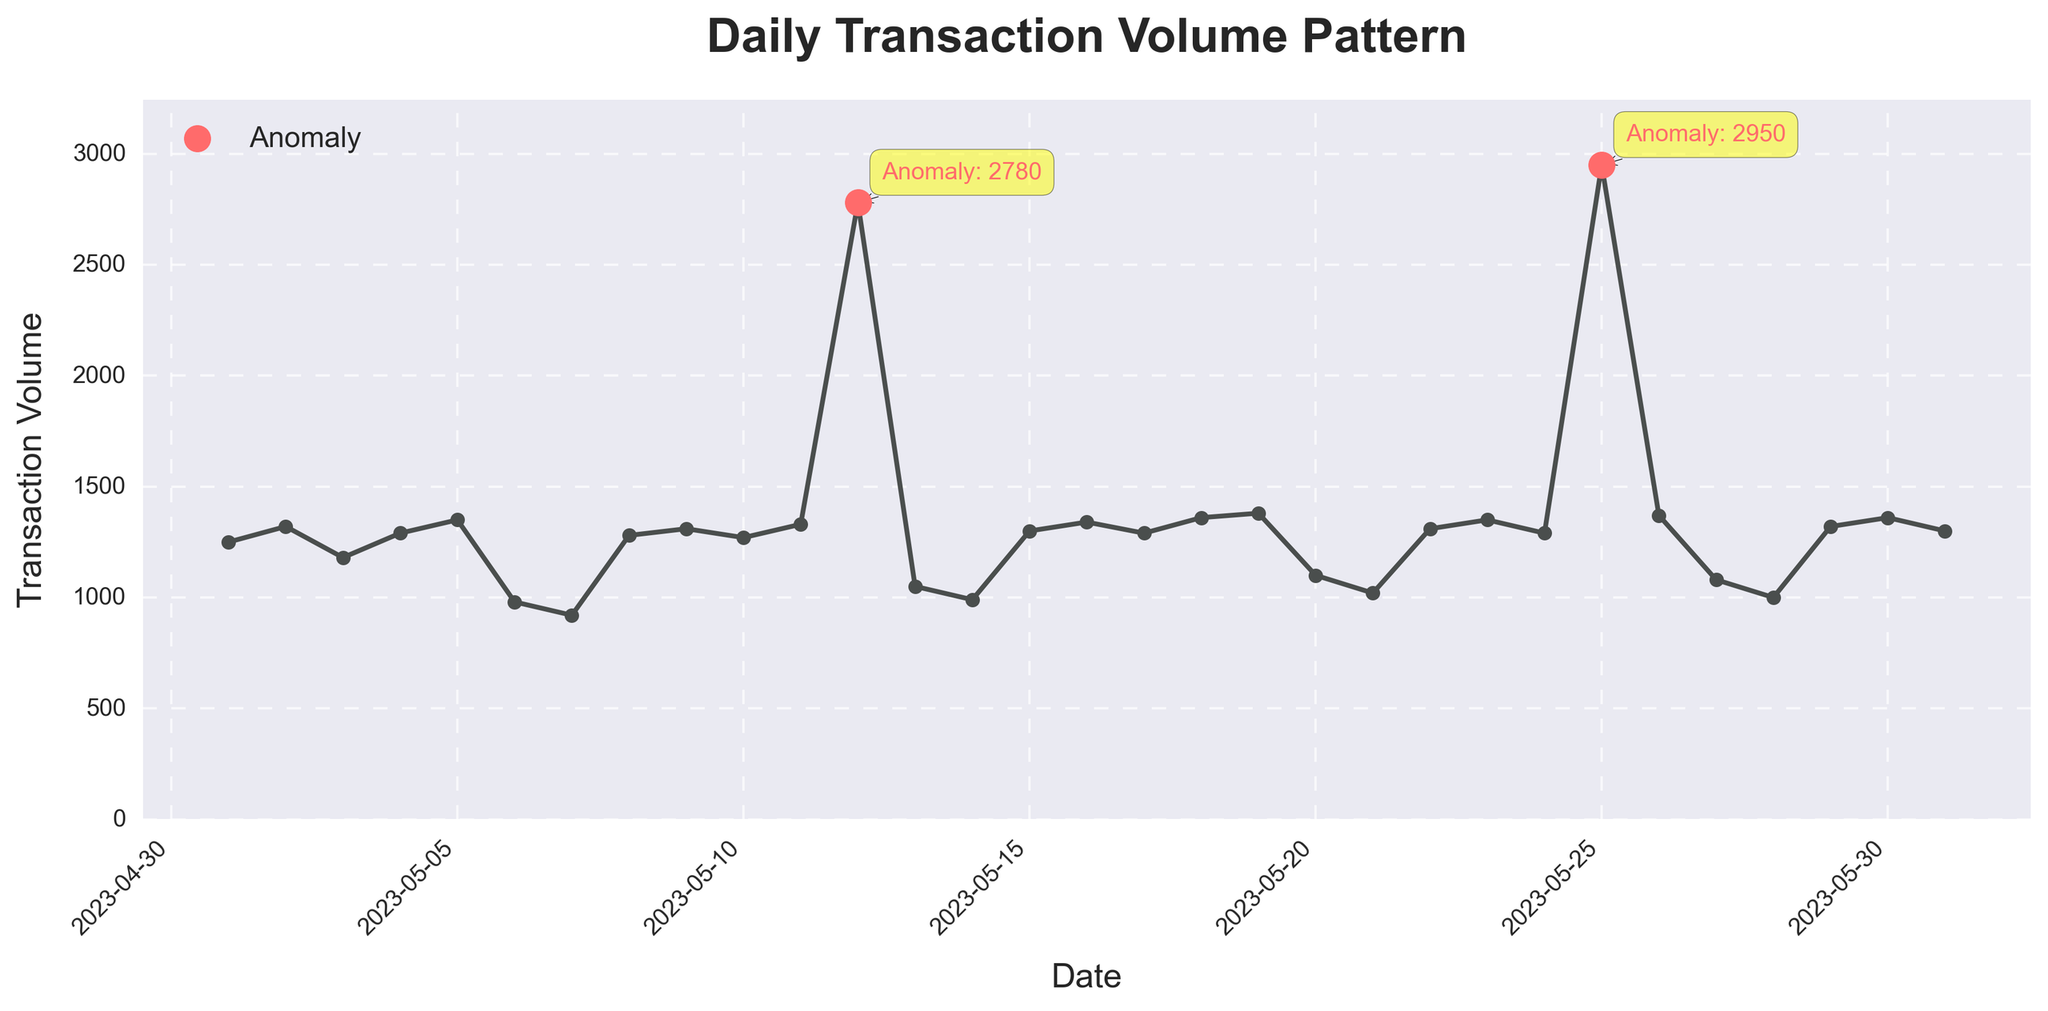What is the pattern of the daily transaction volume from May 1st to May 31st, 2023? The pattern shows relatively consistent transaction volumes ranging between 920 and 1380 units, except on May 12th and May 25th, where there are significant spikes to 2780 and 2950 units respectively.
Answer: Consistent with two significant spikes on May 12th and May 25th What are the dates where transaction volume peaked anomalously? Identifying the red scatter points on the plot which are labeled as anomalies, we see that the peaks are on May 12th and May 25th.
Answer: May 12th and May 25th How does the transaction volume on the anomaly days compare to the average transaction volume of the rest of the days? First, calculate the average transaction volume without anomalies: (sum of non-anomalous days' volumes)/29. Then compare it to the identified anomaly volumes on May 12th (2780) and May 25th (2950).
Answer: Higher than average What is the difference in transaction volume between May 12th and May 25th? Subtract the transaction volume on May 12th from that on May 25th: 2950 - 2780 = 170.
Answer: 170 How many days have transaction volumes below 1000 units? By visually identifying the days on the plot where the volume points are distinctly below 1000 units: May 7th, May 14th, May 20th, and May 21st.
Answer: 4 days Which day has the lowest transaction volume and what was the volume? Identifying the lowest point on the plot, it is on May 7th with a volume of 920 units.
Answer: May 7th, 920 units On which days does the transaction volume exceed 1300 units? By visually checking the plot for days where the transaction volume points are above the 1300 units mark, we find May 5th, May 16th, May 18th, May 19th, May 23rd, May 25th, May 26th, and May 30th.
Answer: May 5th, May 16th, May 18th, May 19th, May 23rd, May 25th, May 26th, May 30th What is the average transaction volume excluding the anomaly dates? Sum the transaction volumes of all the non-anomaly dates and divide by the number of non-anomaly days: ((1250 + 1320 + 1180 + 1290 + 1350 + 980 + 920 + 1280 + 1310 + 1270 + 1330 + 1050 + 990 + 1300 + 1340 + 1290 + 1360 + 1380 + 1100 + 1020 + 1310 + 1350 + 1290 + 1370 + 1080 + 1000 + 1320 + 1360 + 1300) / 29) = (34900 / 29) ≈ 1203.45.
Answer: Approximately 1203.45 